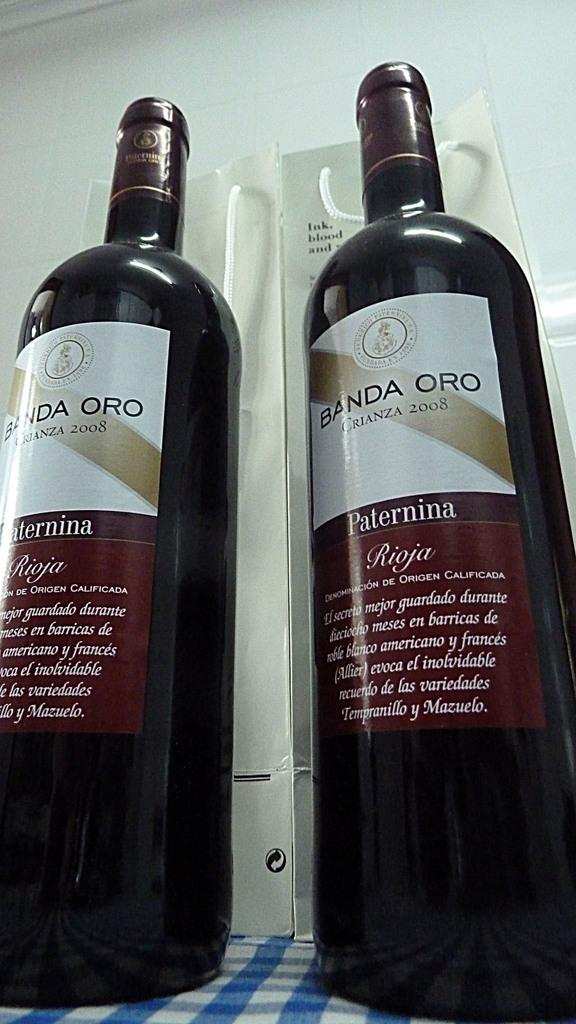<image>
Render a clear and concise summary of the photo. the word banda is on the wine bottles 